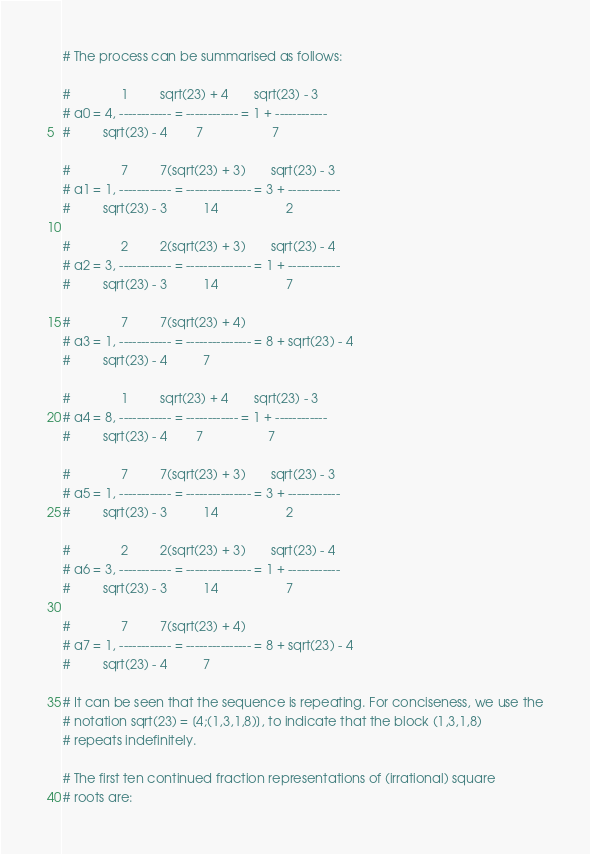<code> <loc_0><loc_0><loc_500><loc_500><_Python_>
# The process can be summarised as follows:

#              1         sqrt(23) + 4       sqrt(23) - 3
# a0 = 4, ------------ = ------------ = 1 + ------------
#         sqrt(23) - 4        7                   7

#              7         7(sqrt(23) + 3)       sqrt(23) - 3
# a1 = 1, ------------ = --------------- = 3 + ------------
#         sqrt(23) - 3          14                   2

#              2         2(sqrt(23) + 3)       sqrt(23) - 4
# a2 = 3, ------------ = --------------- = 1 + ------------
#         sqrt(23) - 3          14                   7

#              7         7(sqrt(23) + 4)
# a3 = 1, ------------ = --------------- = 8 + sqrt(23) - 4
#         sqrt(23) - 4          7

#              1         sqrt(23) + 4       sqrt(23) - 3
# a4 = 8, ------------ = ------------ = 1 + ------------
#         sqrt(23) - 4        7                  7

#              7         7(sqrt(23) + 3)       sqrt(23) - 3
# a5 = 1, ------------ = --------------- = 3 + ------------
#         sqrt(23) - 3          14                   2

#              2         2(sqrt(23) + 3)       sqrt(23) - 4
# a6 = 3, ------------ = --------------- = 1 + ------------
#         sqrt(23) - 3          14                   7

#              7         7(sqrt(23) + 4)
# a7 = 1, ------------ = --------------- = 8 + sqrt(23) - 4
#         sqrt(23) - 4          7

# It can be seen that the sequence is repeating. For conciseness, we use the
# notation sqrt(23) = [4;(1,3,1,8)], to indicate that the block (1,3,1,8)
# repeats indefinitely.

# The first ten continued fraction representations of (irrational) square
# roots are:
</code> 